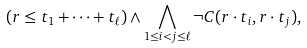<formula> <loc_0><loc_0><loc_500><loc_500>( r \leq t _ { 1 } + \cdots + t _ { \ell } ) \wedge \bigwedge _ { 1 \leq i < j \leq \ell } \neg C ( r \cdot t _ { i } , r \cdot t _ { j } ) ,</formula> 